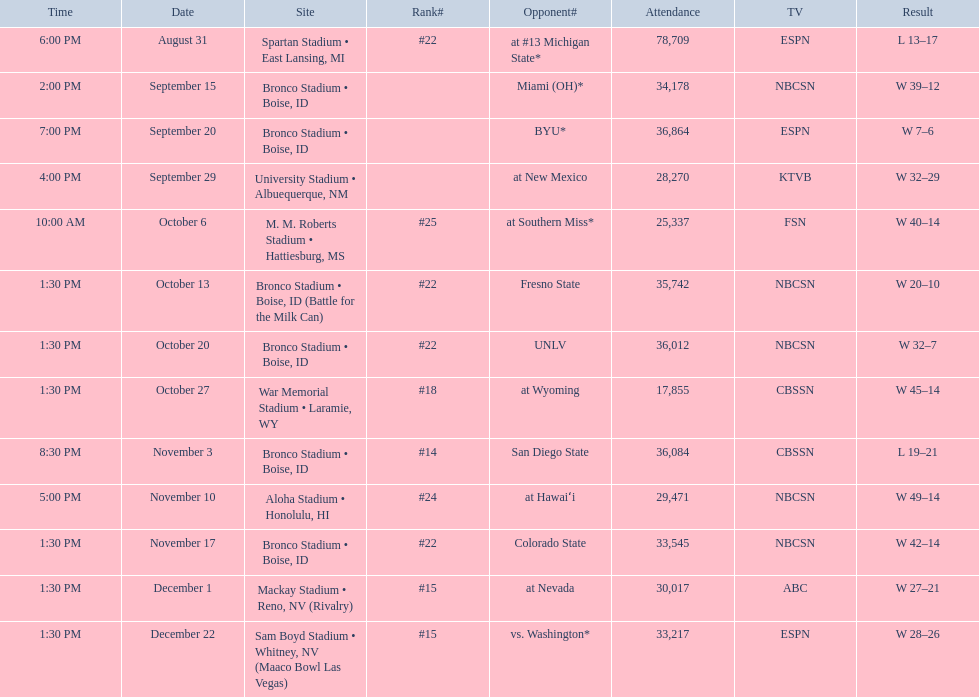Could you help me parse every detail presented in this table? {'header': ['Time', 'Date', 'Site', 'Rank#', 'Opponent#', 'Attendance', 'TV', 'Result'], 'rows': [['6:00 PM', 'August 31', 'Spartan Stadium • East Lansing, MI', '#22', 'at\xa0#13\xa0Michigan State*', '78,709', 'ESPN', 'L\xa013–17'], ['2:00 PM', 'September 15', 'Bronco Stadium • Boise, ID', '', 'Miami (OH)*', '34,178', 'NBCSN', 'W\xa039–12'], ['7:00 PM', 'September 20', 'Bronco Stadium • Boise, ID', '', 'BYU*', '36,864', 'ESPN', 'W\xa07–6'], ['4:00 PM', 'September 29', 'University Stadium • Albuequerque, NM', '', 'at\xa0New Mexico', '28,270', 'KTVB', 'W\xa032–29'], ['10:00 AM', 'October 6', 'M. M. Roberts Stadium • Hattiesburg, MS', '#25', 'at\xa0Southern Miss*', '25,337', 'FSN', 'W\xa040–14'], ['1:30 PM', 'October 13', 'Bronco Stadium • Boise, ID (Battle for the Milk Can)', '#22', 'Fresno State', '35,742', 'NBCSN', 'W\xa020–10'], ['1:30 PM', 'October 20', 'Bronco Stadium • Boise, ID', '#22', 'UNLV', '36,012', 'NBCSN', 'W\xa032–7'], ['1:30 PM', 'October 27', 'War Memorial Stadium • Laramie, WY', '#18', 'at\xa0Wyoming', '17,855', 'CBSSN', 'W\xa045–14'], ['8:30 PM', 'November 3', 'Bronco Stadium • Boise, ID', '#14', 'San Diego State', '36,084', 'CBSSN', 'L\xa019–21'], ['5:00 PM', 'November 10', 'Aloha Stadium • Honolulu, HI', '#24', 'at\xa0Hawaiʻi', '29,471', 'NBCSN', 'W\xa049–14'], ['1:30 PM', 'November 17', 'Bronco Stadium • Boise, ID', '#22', 'Colorado State', '33,545', 'NBCSN', 'W\xa042–14'], ['1:30 PM', 'December 1', 'Mackay Stadium • Reno, NV (Rivalry)', '#15', 'at\xa0Nevada', '30,017', 'ABC', 'W\xa027–21'], ['1:30 PM', 'December 22', 'Sam Boyd Stadium • Whitney, NV (Maaco Bowl Las Vegas)', '#15', 'vs.\xa0Washington*', '33,217', 'ESPN', 'W\xa028–26']]} What rank was boise state after november 10th? #22. 